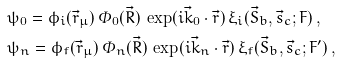Convert formula to latex. <formula><loc_0><loc_0><loc_500><loc_500>& \psi _ { 0 } = \phi _ { i } ( \vec { r } _ { \mu } ) \, \varPhi _ { 0 } ( \vec { R } ) \, \exp ( i \vec { k } _ { 0 } \cdot \vec { r } ) \, \xi _ { i } ( \vec { S } _ { b } , \vec { s } _ { c } ; F ) \, , \\ & \psi _ { n } = \phi _ { f } ( \vec { r } _ { \mu } ) \, \varPhi _ { n } ( \vec { R } ) \, \exp ( i \vec { k } _ { n } \cdot \vec { r } ) \, \xi _ { f } ( \vec { S } _ { b } , \vec { s } _ { c } ; F ^ { \prime } ) \, ,</formula> 